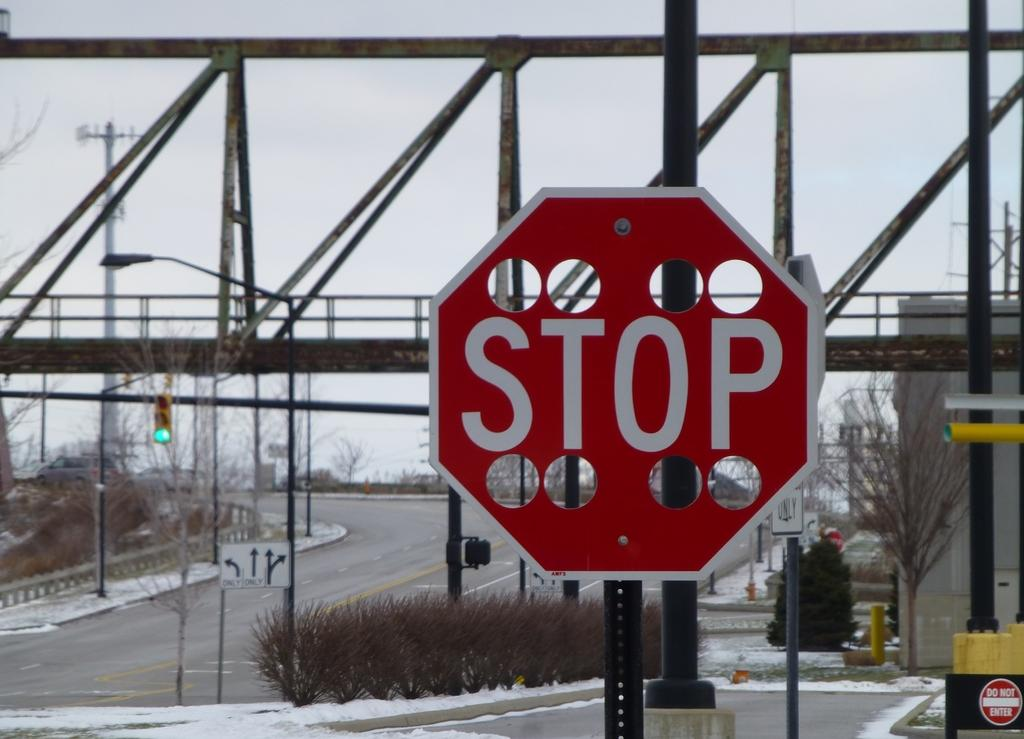<image>
Create a compact narrative representing the image presented. A classic red stop sign is perforated with eight symmetrical holes. 